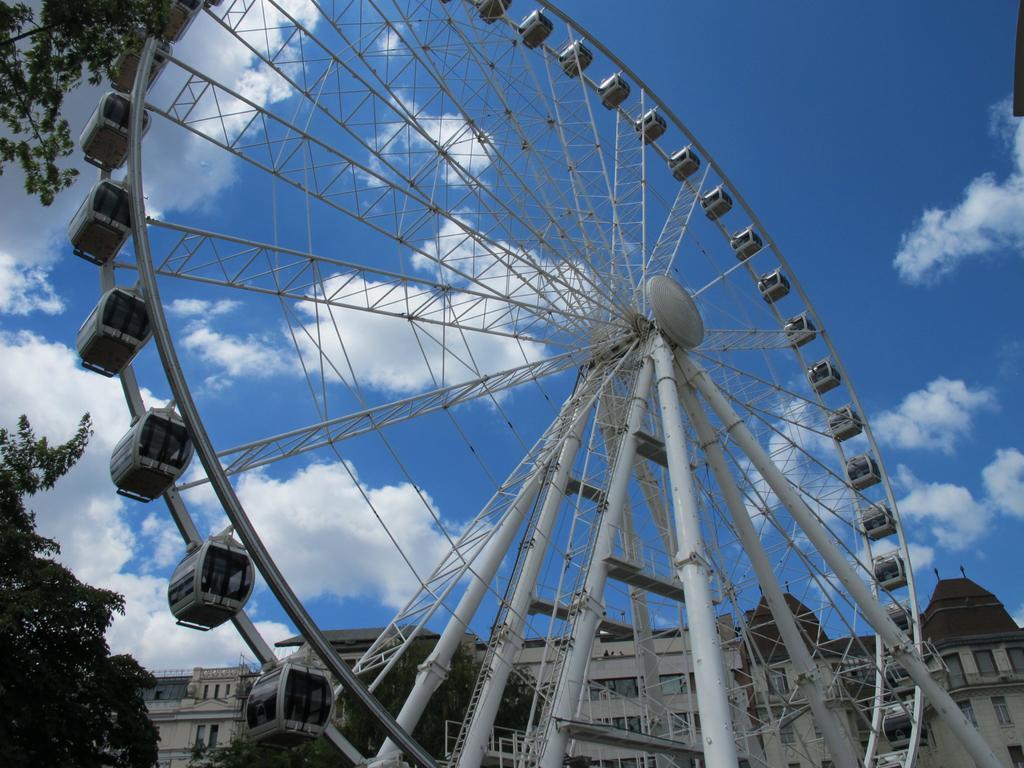Can you describe this image briefly? In this image in the front there is a giant wheel which is white in colour. On the left side there are leaves. In the background there is a building and the sky is cloudy. 